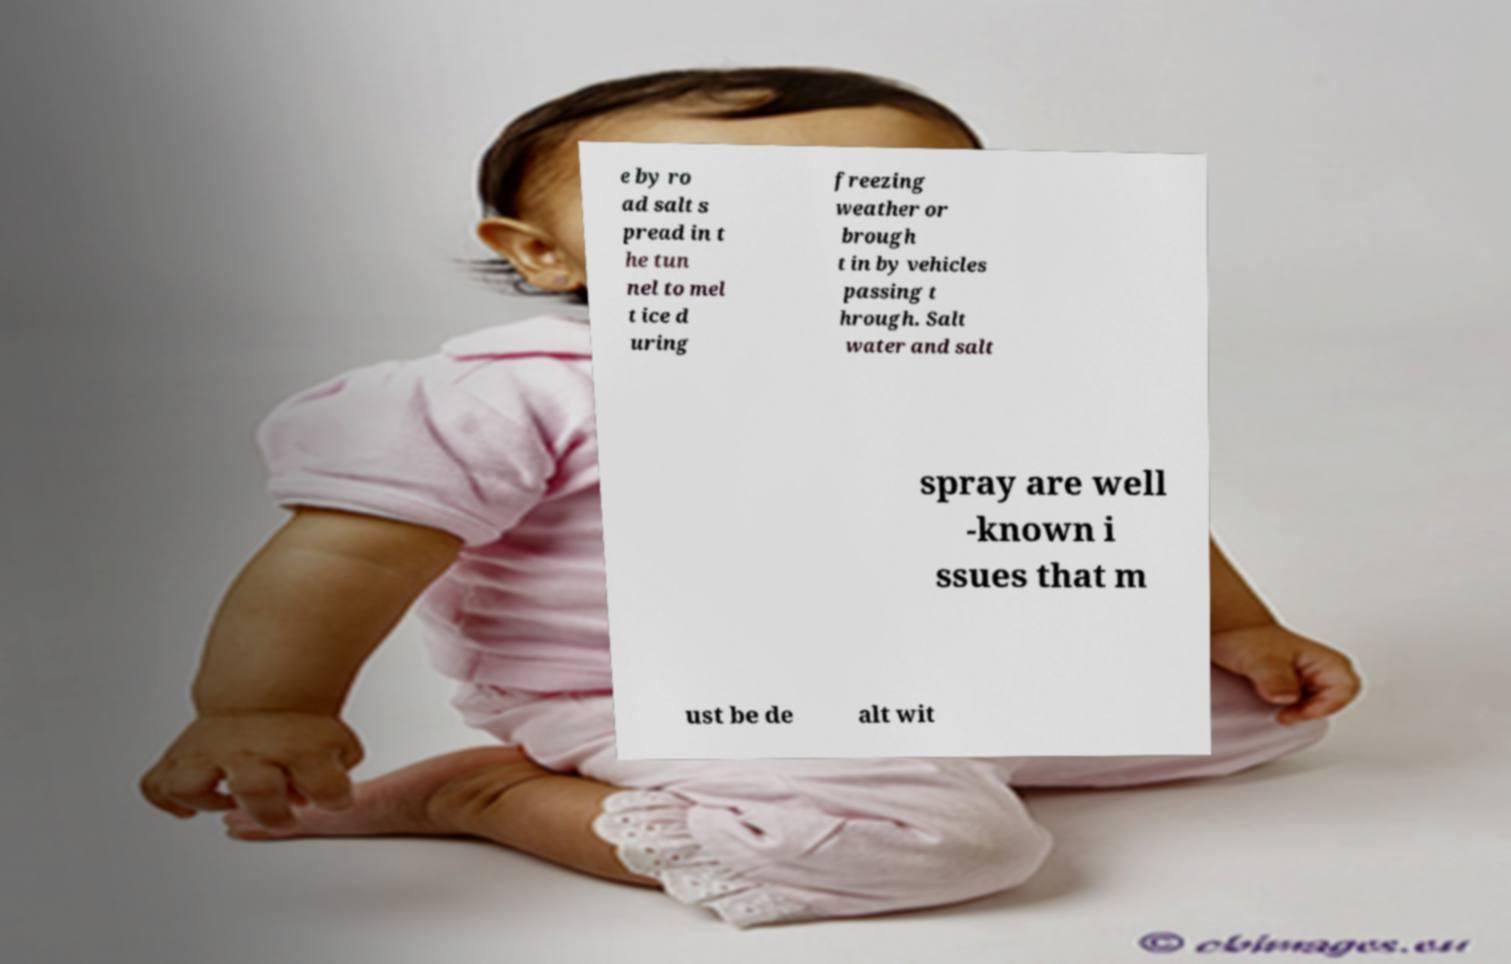Could you extract and type out the text from this image? e by ro ad salt s pread in t he tun nel to mel t ice d uring freezing weather or brough t in by vehicles passing t hrough. Salt water and salt spray are well -known i ssues that m ust be de alt wit 